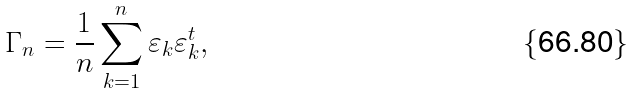<formula> <loc_0><loc_0><loc_500><loc_500>\Gamma _ { n } = \frac { 1 } { n } \sum _ { k = 1 } ^ { n } \varepsilon _ { k } \varepsilon _ { k } ^ { t } ,</formula> 